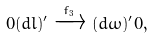<formula> <loc_0><loc_0><loc_500><loc_500>0 ( d l ) ^ { \prime } \xrightarrow { f _ { 3 } } ( d \omega ) ^ { \prime } 0 ,</formula> 